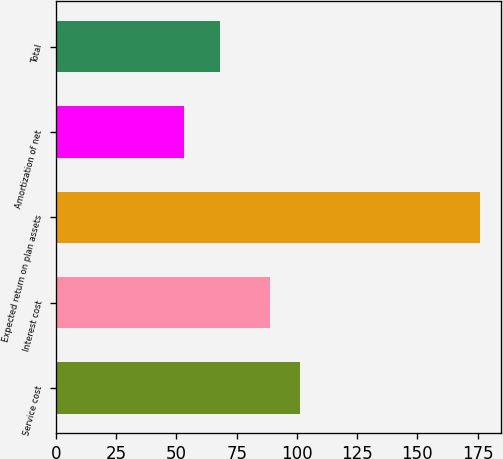<chart> <loc_0><loc_0><loc_500><loc_500><bar_chart><fcel>Service cost<fcel>Interest cost<fcel>Expected return on plan assets<fcel>Amortization of net<fcel>Total<nl><fcel>101.3<fcel>89<fcel>176<fcel>53<fcel>68<nl></chart> 